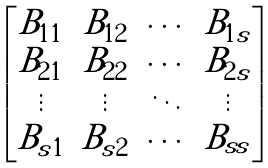<formula> <loc_0><loc_0><loc_500><loc_500>\begin{bmatrix} B _ { 1 1 } & B _ { 1 2 } & \cdots & B _ { 1 s } \\ B _ { 2 1 } & B _ { 2 2 } & \cdots & B _ { 2 s } \\ \vdots & \vdots & \ddots & \vdots \\ B _ { s 1 } & B _ { s 2 } & \cdots & B _ { s s } \end{bmatrix}</formula> 